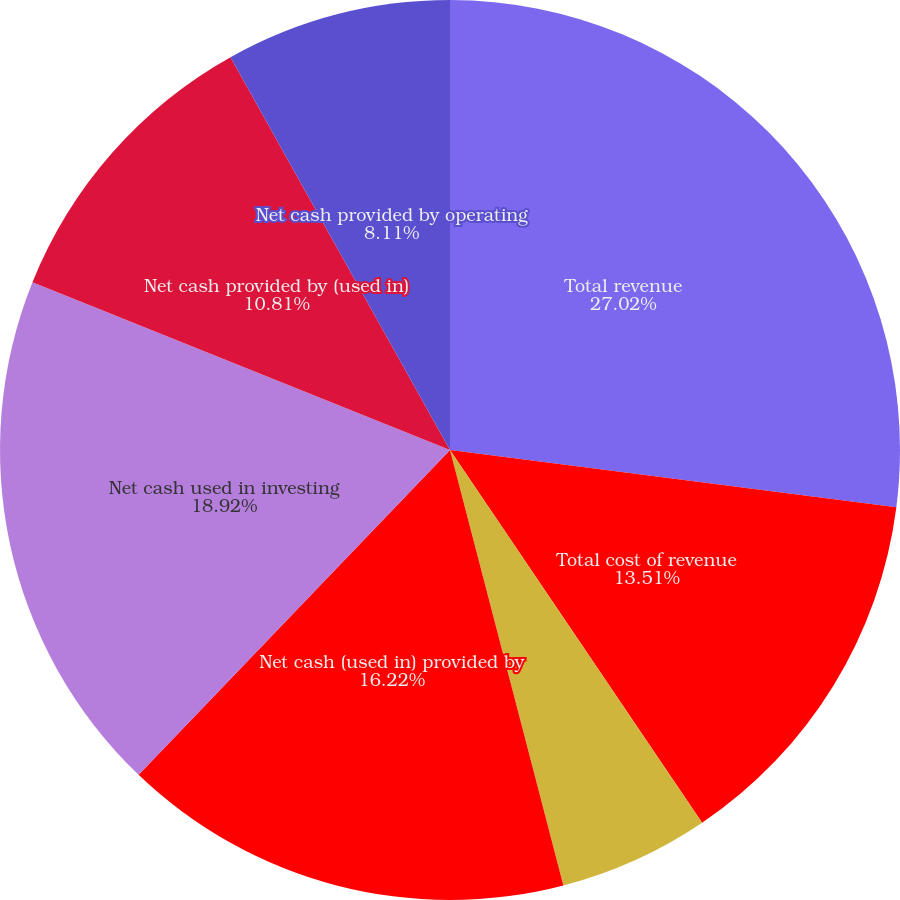Convert chart. <chart><loc_0><loc_0><loc_500><loc_500><pie_chart><fcel>Total revenue<fcel>Total cost of revenue<fcel>Net income (loss)<fcel>Net income (loss) per share<fcel>Net cash (used in) provided by<fcel>Net cash used in investing<fcel>Net cash provided by (used in)<fcel>Net cash provided by operating<nl><fcel>27.03%<fcel>13.51%<fcel>5.41%<fcel>0.0%<fcel>16.22%<fcel>18.92%<fcel>10.81%<fcel>8.11%<nl></chart> 